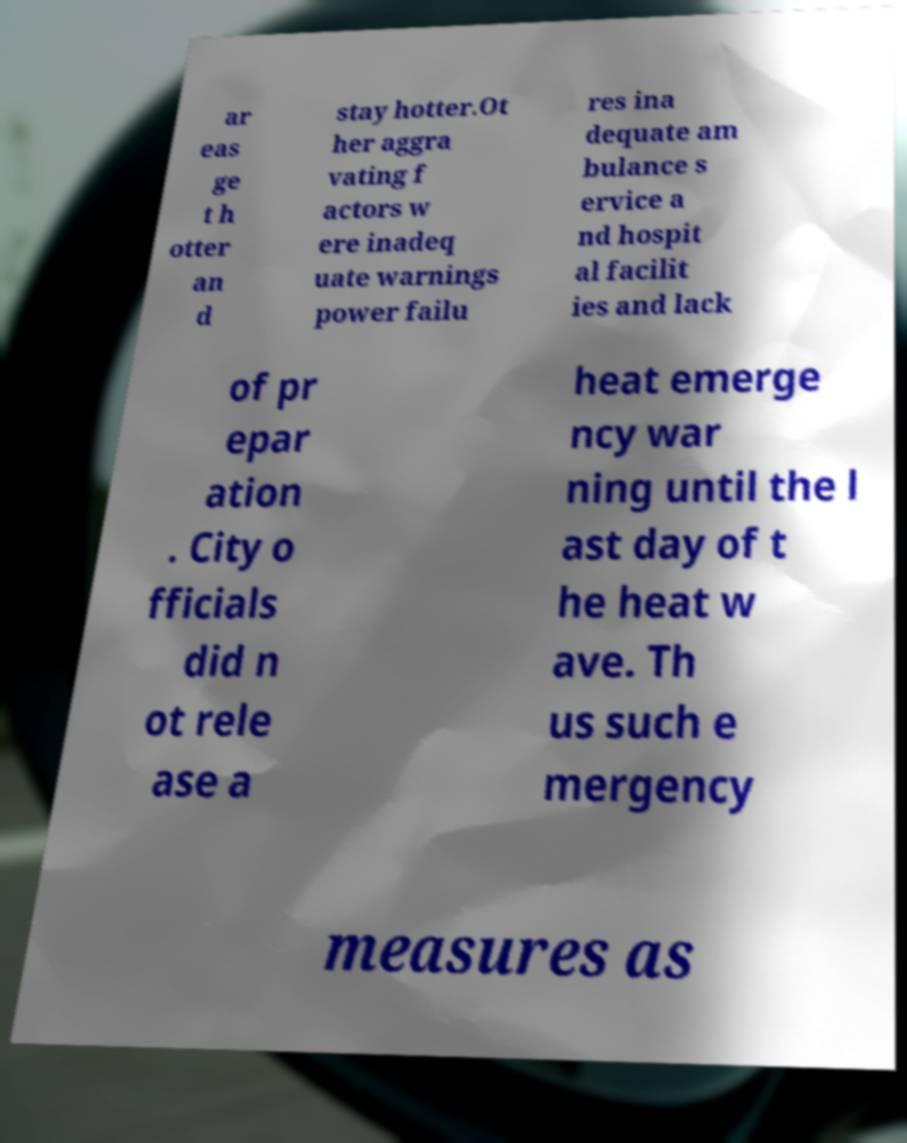I need the written content from this picture converted into text. Can you do that? ar eas ge t h otter an d stay hotter.Ot her aggra vating f actors w ere inadeq uate warnings power failu res ina dequate am bulance s ervice a nd hospit al facilit ies and lack of pr epar ation . City o fficials did n ot rele ase a heat emerge ncy war ning until the l ast day of t he heat w ave. Th us such e mergency measures as 